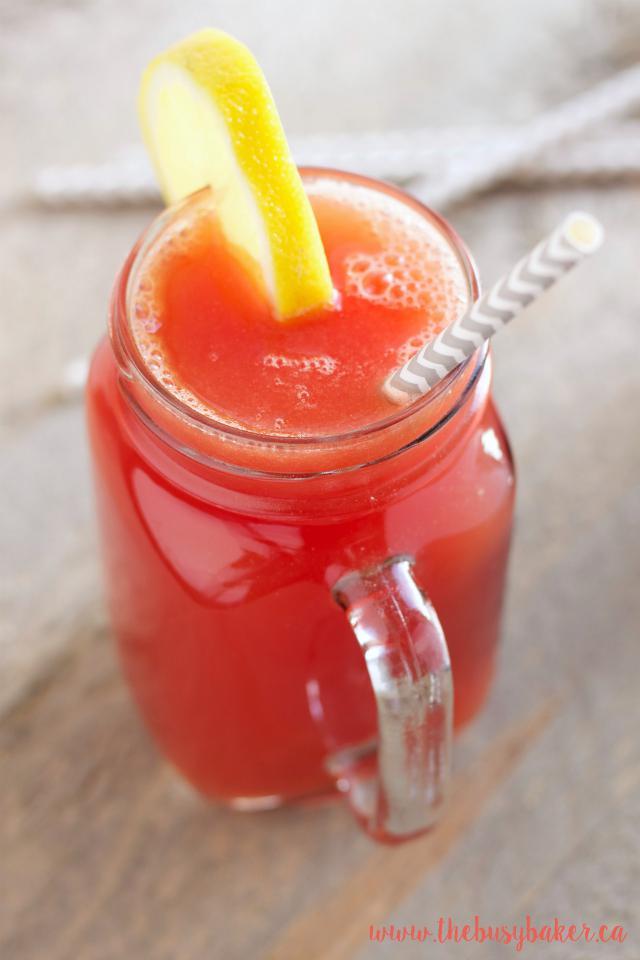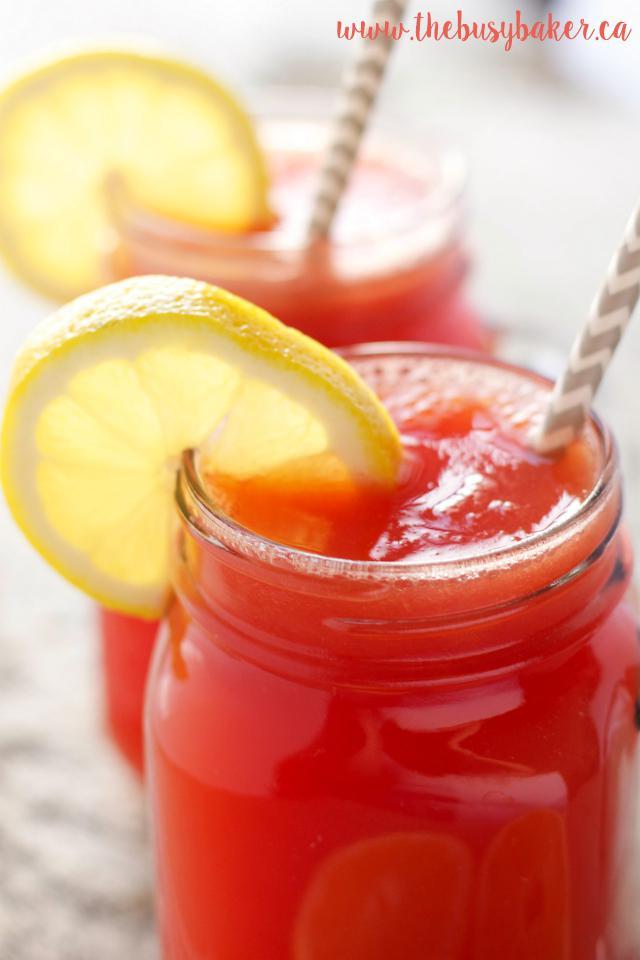The first image is the image on the left, the second image is the image on the right. For the images shown, is this caption "At least some of the beverages are served in jars and have straws inserted." true? Answer yes or no. Yes. The first image is the image on the left, the second image is the image on the right. Given the left and right images, does the statement "Both images show a red drink in a clear glass with a lemon slice on the edge of the glass" hold true? Answer yes or no. Yes. 